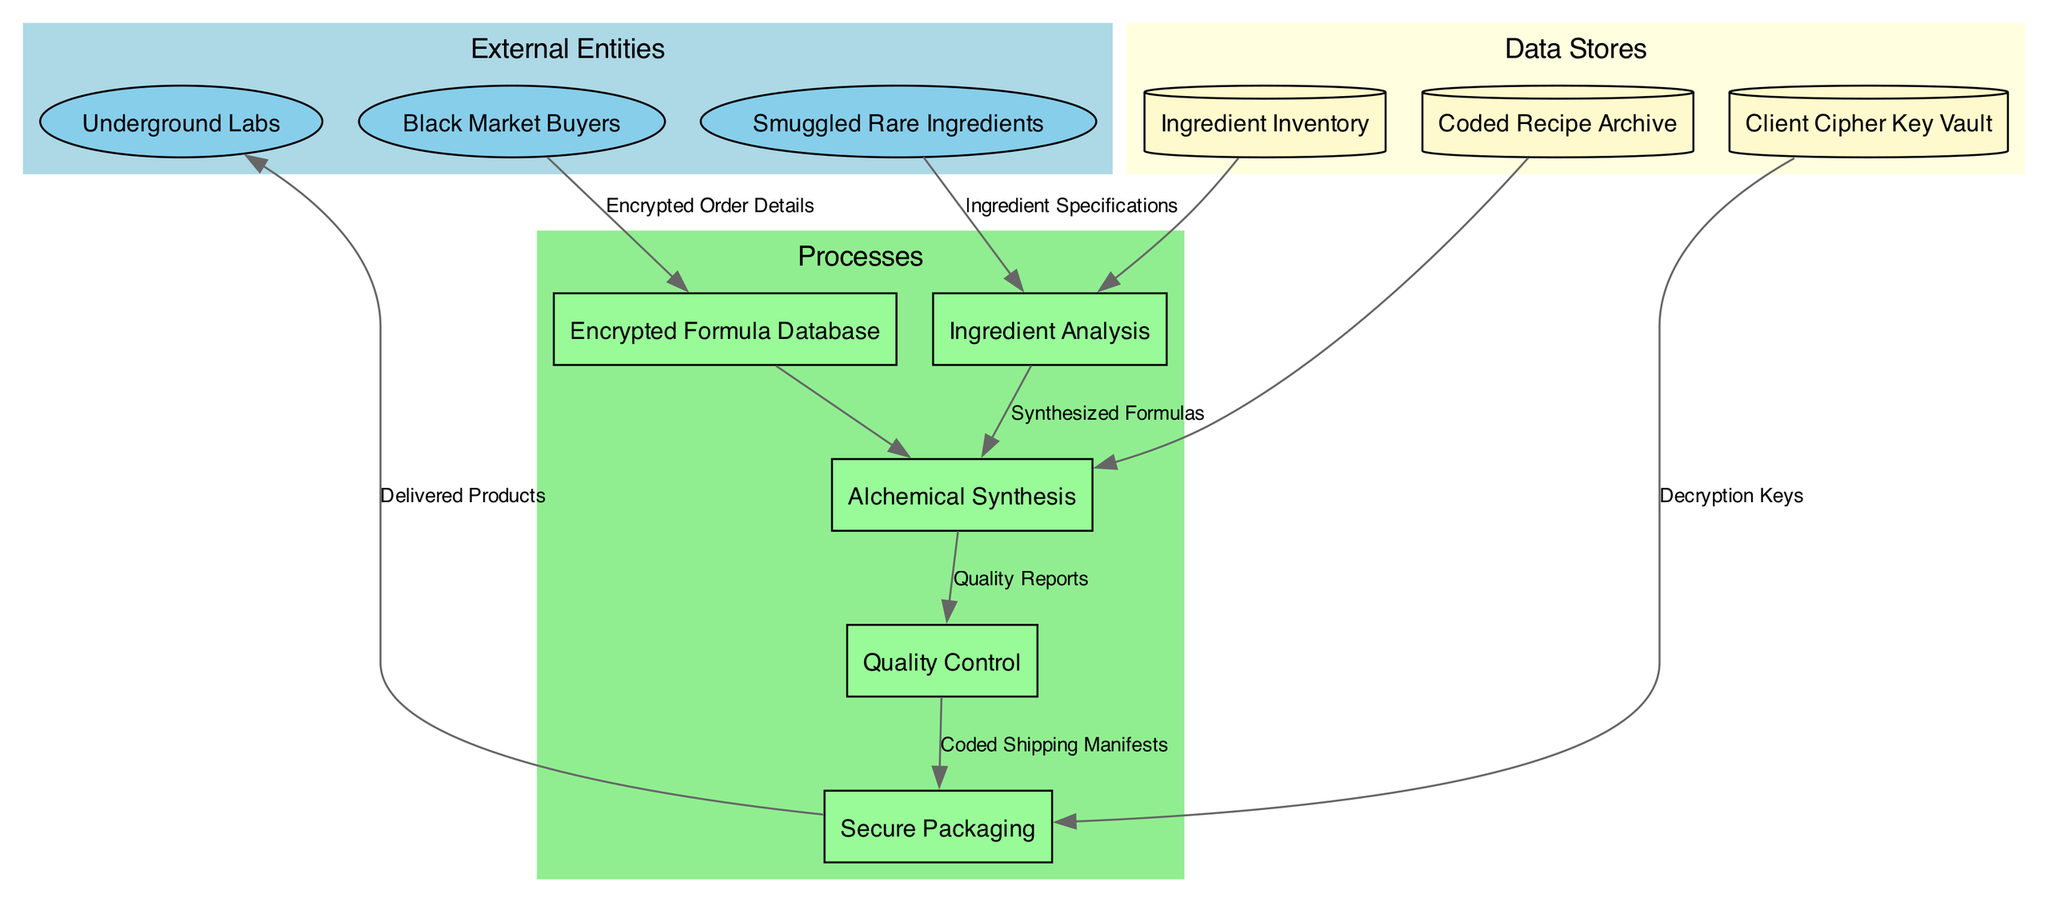What are the external entities in this workflow? The external entities are labeled within the diagram and include "Black Market Buyers," "Smuggled Rare Ingredients," and "Underground Labs."
Answer: Black Market Buyers, Smuggled Rare Ingredients, Underground Labs How many processes are represented in the diagram? The diagram contains five distinct processes, which can be counted by looking at the labeled boxes in the "Processes" section.
Answer: Five What is the flow of data from "Ingredient Analysis" to "Quality Control"? The data flows from "Ingredient Analysis" to "Alchemical Synthesis," and then from "Alchemical Synthesis" to "Quality Control," representing a sequential process connected by edges in the diagram.
Answer: Synthesized Formulas Which data store is associated with client security? The diagram specifies "Client Cipher Key Vault" as a data store related to client security, indicated by its placement within the "Data Stores" cluster.
Answer: Client Cipher Key Vault What type of nodes represent the "External Entities"? The "External Entities" are represented with elliptical shapes in the diagram, distinguishing them from other node types.
Answer: Ellipses Which process receives data from both "Smuggled Rare Ingredients" and "Ingredient Inventory"? The "Ingredient Analysis" process receives data from both "Smuggled Rare Ingredients" and "Ingredient Inventory," as indicated by the edges connecting these entities to it.
Answer: Ingredient Analysis What is the last step before products are delivered? The last step before products are delivered is "Secure Packaging," which links directly to "Underground Labs," reflecting the final action in the workflow prior to delivery.
Answer: Secure Packaging How many data flows in total are shown in the diagram? The diagram displays six distinct data flows, which can be counted by examining the edges connecting the nodes in the workflow.
Answer: Six 